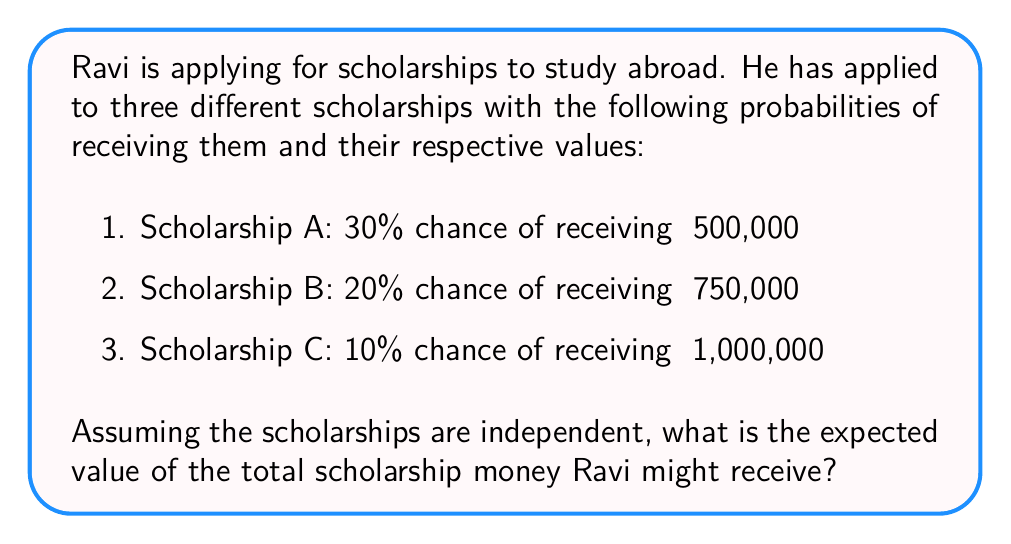Provide a solution to this math problem. To solve this problem, we'll follow these steps:

1. Calculate the expected value of each scholarship individually.
2. Sum up the expected values to get the total expected value.

Step 1: Calculate the expected value of each scholarship

The expected value is calculated by multiplying the probability of an event by its value.

For Scholarship A:
$E(A) = 0.30 \times ₹500,000 = ₹150,000$

For Scholarship B:
$E(B) = 0.20 \times ₹750,000 = ₹150,000$

For Scholarship C:
$E(C) = 0.10 \times ₹1,000,000 = ₹100,000$

Step 2: Sum up the expected values

Since the scholarships are independent, we can add their individual expected values to get the total expected value.

$E(\text{Total}) = E(A) + E(B) + E(C)$
$E(\text{Total}) = ₹150,000 + ₹150,000 + ₹100,000 = ₹400,000$

Therefore, the expected value of the total scholarship money Ravi might receive is ₹400,000.
Answer: ₹400,000 